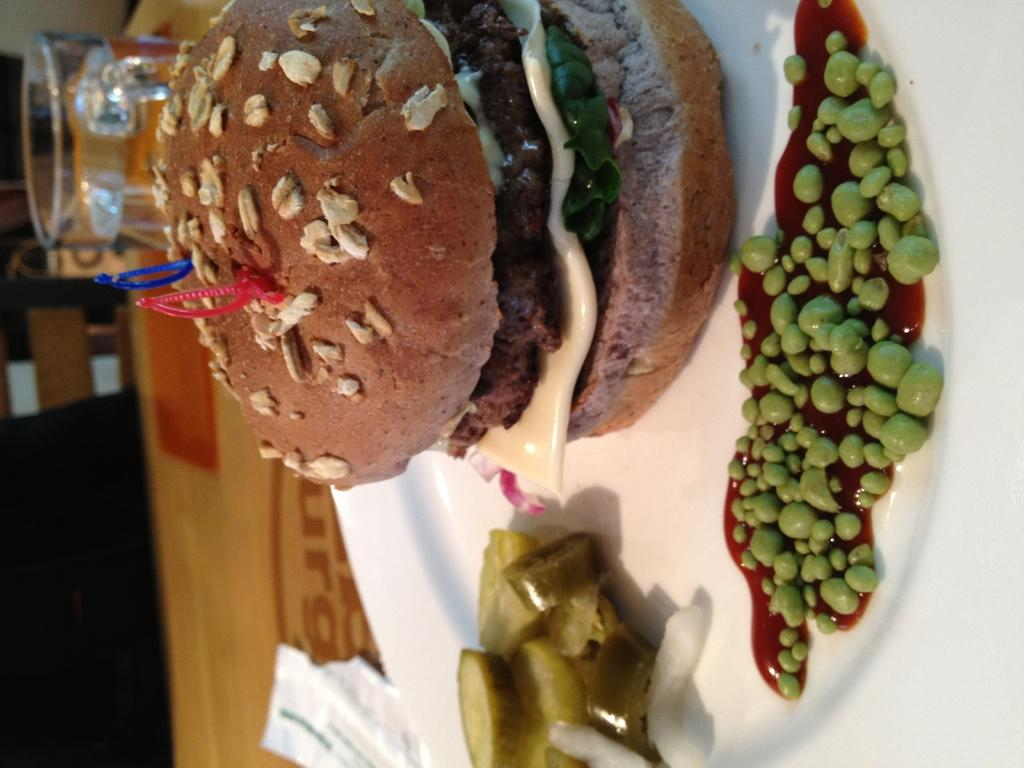What is the main food item visible in the image? There is a burger in the image. What is the color of the plate that holds the food items? The plate is white. What type of table is the plate placed on? The plate is on a wooden table. Are there any other objects on the wooden table? Yes, there are other objects on the wooden table. What color are the eyes of the substance on the wooden table? There are no eyes or substances with eyes present in the image. 